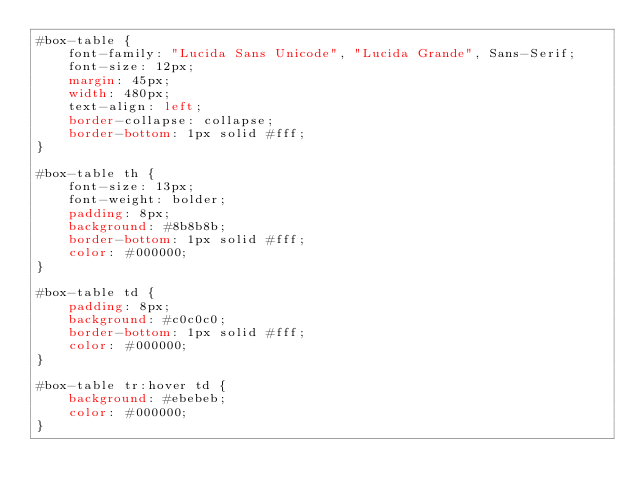<code> <loc_0><loc_0><loc_500><loc_500><_CSS_>#box-table {
    font-family: "Lucida Sans Unicode", "Lucida Grande", Sans-Serif;
    font-size: 12px;
    margin: 45px;
    width: 480px;
    text-align: left;
    border-collapse: collapse;
    border-bottom: 1px solid #fff;
}

#box-table th {
    font-size: 13px;
    font-weight: bolder;
    padding: 8px;
    background: #8b8b8b;
    border-bottom: 1px solid #fff;
    color: #000000;
}

#box-table td {
    padding: 8px;
    background: #c0c0c0;
    border-bottom: 1px solid #fff;
    color: #000000;
}

#box-table tr:hover td {
    background: #ebebeb;
    color: #000000;
}</code> 